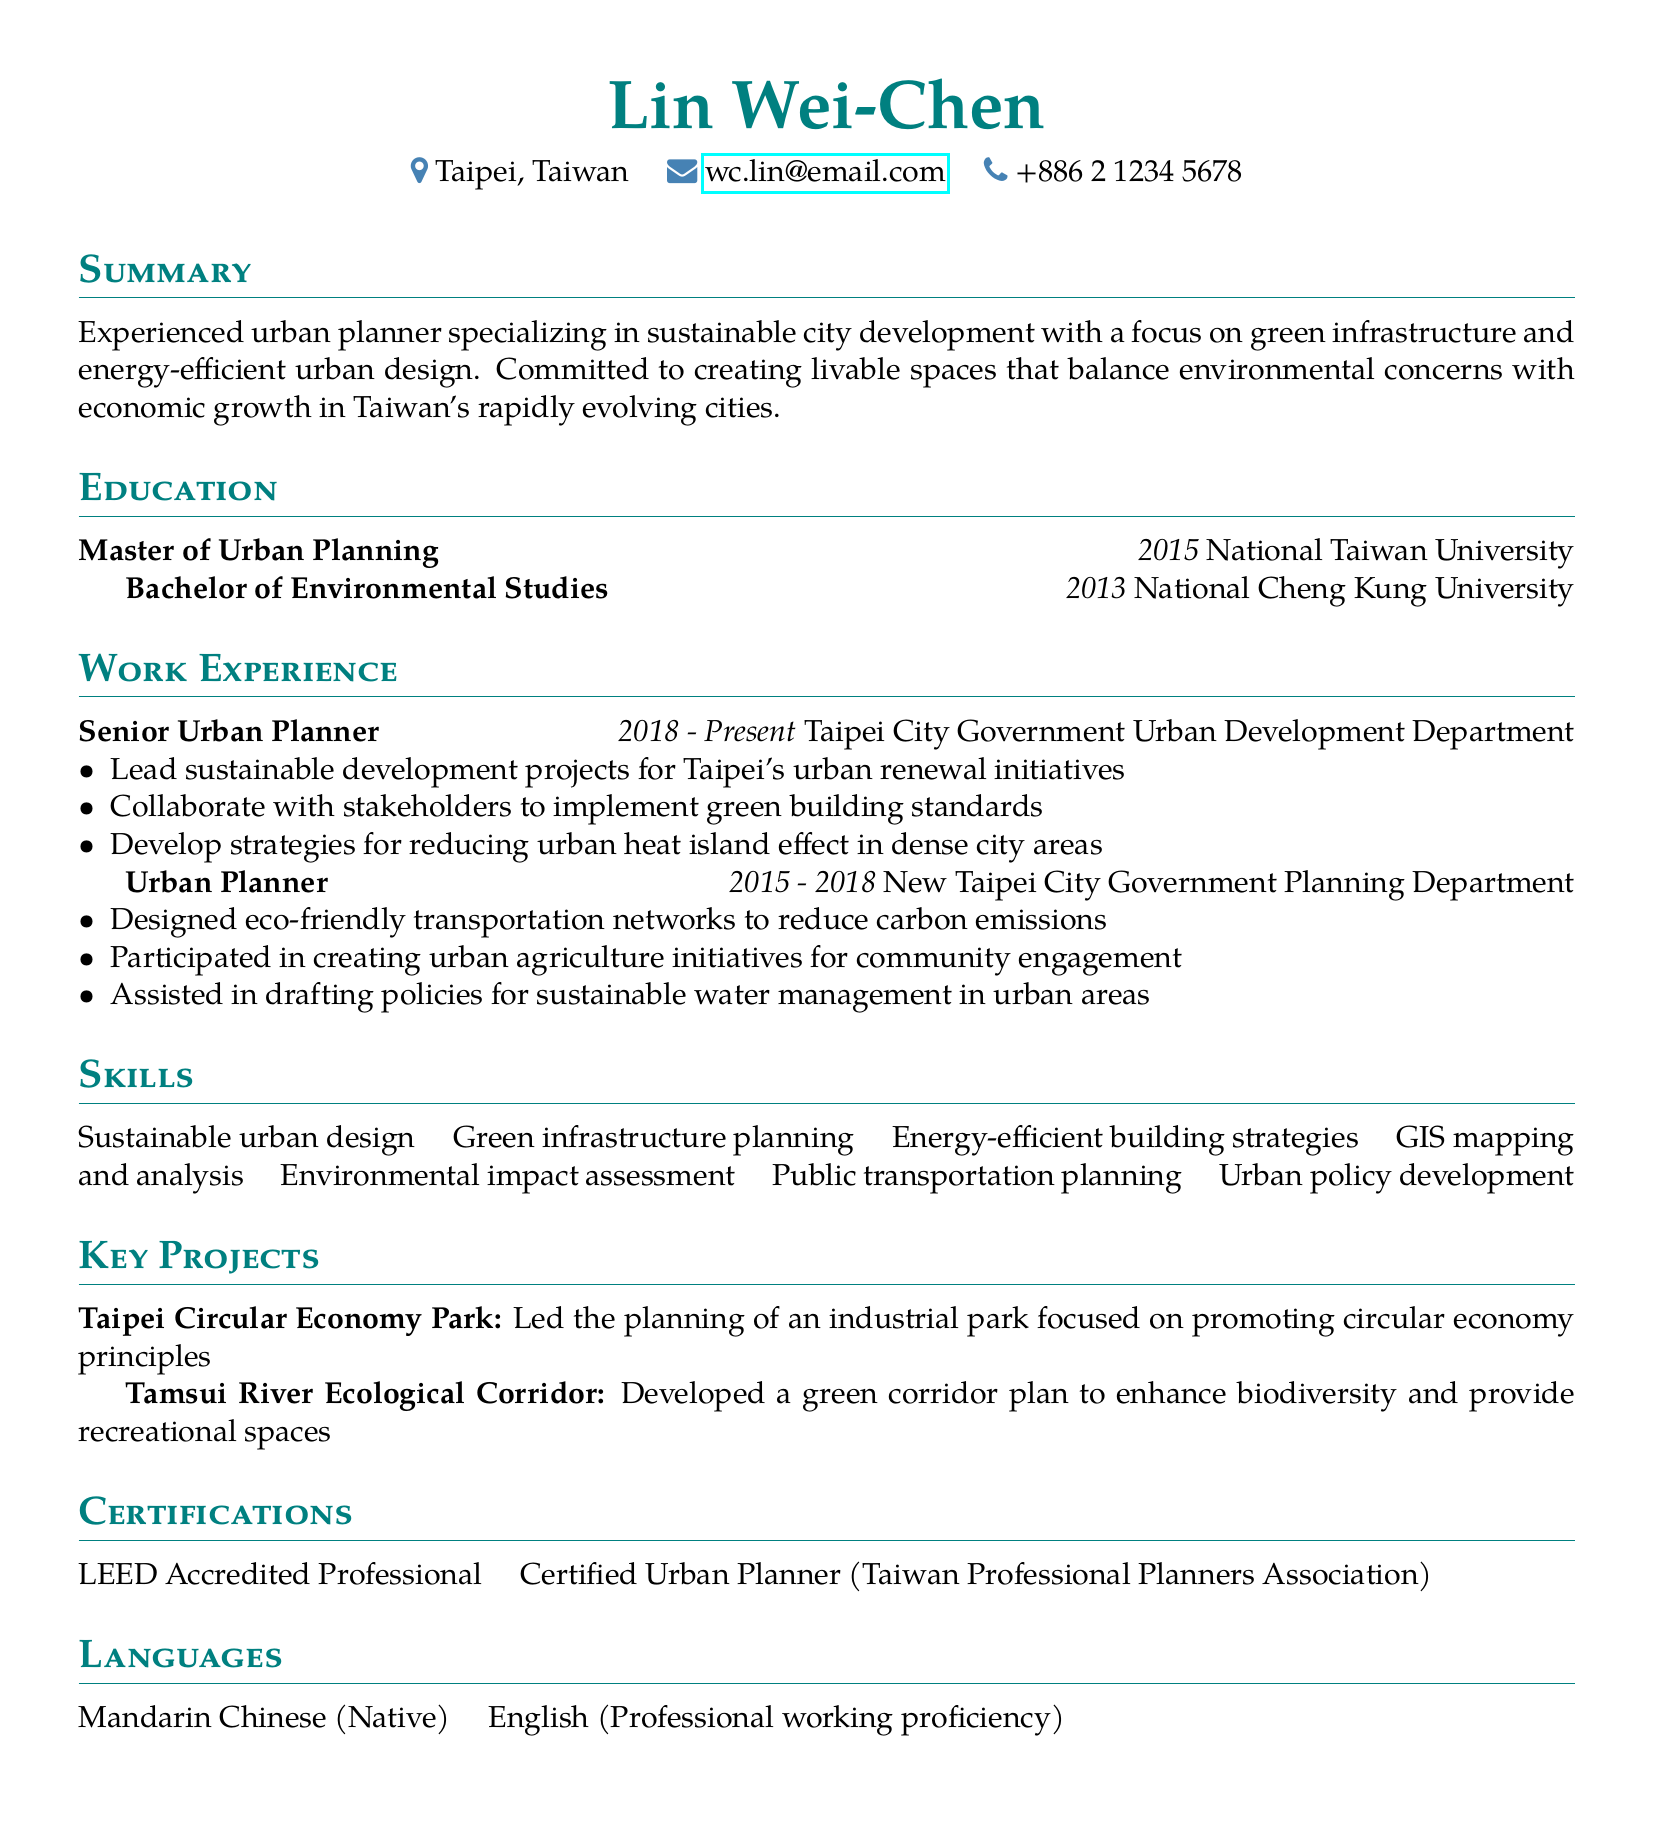What is the name of the individual? The name of the individual is listed at the top of the document.
Answer: Lin Wei-Chen What is the total duration of work experience? The duration from the work experience sections shows 2015 to present, totaling 8 years.
Answer: 8 years Which university awarded the Master's degree? The educational background section specifies the institution of the Master's degree.
Answer: National Taiwan University What is one of the main responsibilities of the Senior Urban Planner? A specific responsibility listed under the work experience section for the Senior Urban Planner role needs to be referenced.
Answer: Lead sustainable development projects What certification is held by Lin Wei-Chen? The certifications section lists the recognized qualifications of the individual.
Answer: LEED Accredited Professional What is the primary focus of the projects listed? The project descriptions highlight the main themes of the initiatives undertaken by the individual.
Answer: Sustainable development How many languages can Lin Wei-Chen speak? The languages section notes the count of languages mentioned.
Answer: 2 languages What does Lin Wei-Chen specialize in? The summary at the beginning indicates the main area of expertise of the individual.
Answer: Sustainable city development What was the role in the New Taipei City Government? The work experience section details the specific title for the role held in this organization.
Answer: Urban Planner 